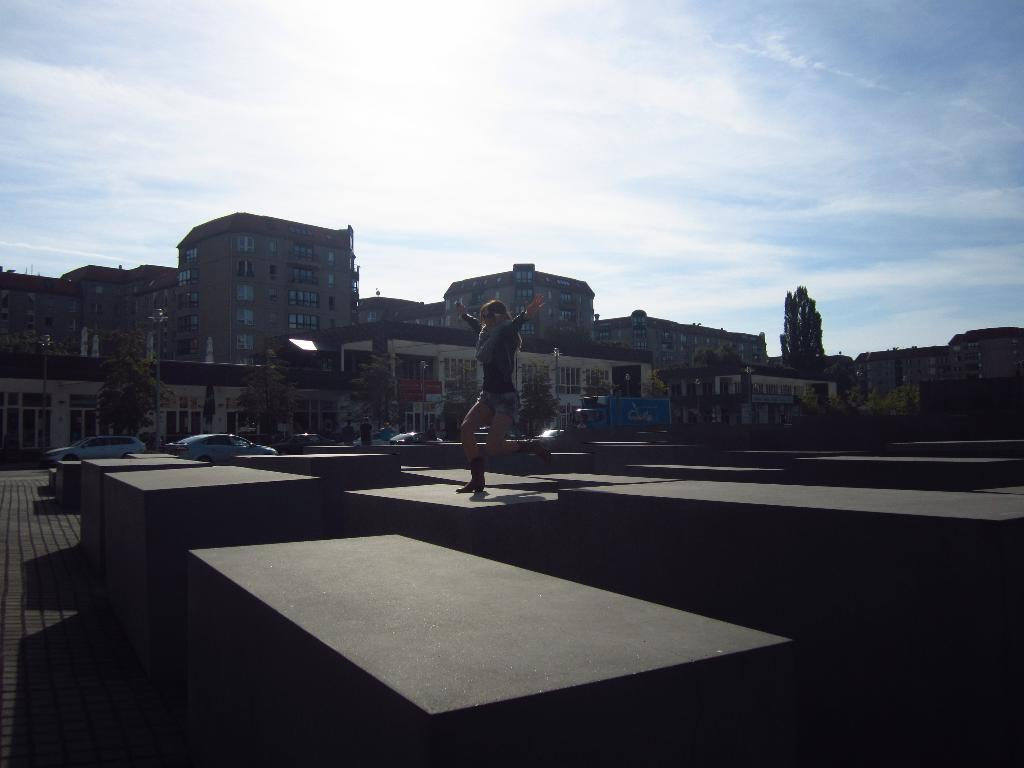Who or what is the main subject in the image? There is a person in the image. What objects are visible with the person? There are blocks in the image. Can you describe the background of the image? There are people, vehicles, trees, buildings, and the sky visible in the background of the image. What type of basketball is the person holding in the image? There is no basketball present in the image. What color is the coat the person is wearing in the image? The person in the image is not wearing a coat, so we cannot determine the color. 